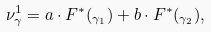<formula> <loc_0><loc_0><loc_500><loc_500>\nu _ { \gamma } ^ { 1 } = a \cdot F ^ { \ast } ( _ { \gamma _ { 1 } } ) + b \cdot F ^ { \ast } ( _ { \gamma _ { 2 } } ) ,</formula> 